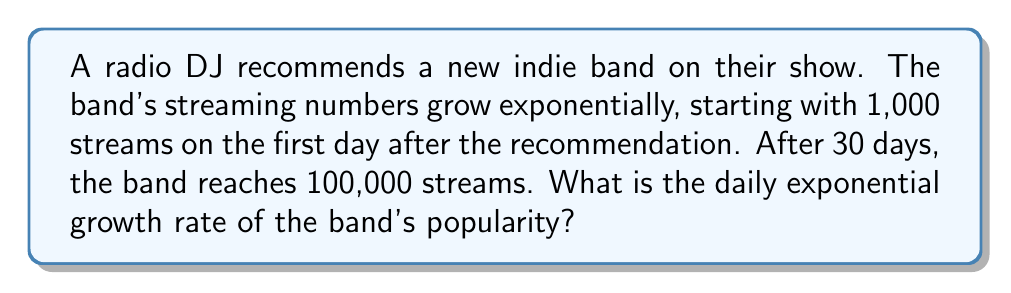Solve this math problem. Let's approach this step-by-step using the exponential growth formula:

1) The exponential growth formula is:
   $$A = P(1 + r)^t$$
   Where:
   $A$ = Final amount
   $P$ = Initial amount
   $r$ = Daily growth rate (in decimal form)
   $t$ = Time period (in days)

2) We know:
   $P = 1,000$ (initial streams)
   $A = 100,000$ (final streams)
   $t = 30$ days

3) Let's plug these into our formula:
   $$100,000 = 1,000(1 + r)^{30}$$

4) Simplify:
   $$100 = (1 + r)^{30}$$

5) Take the 30th root of both sides:
   $$\sqrt[30]{100} = 1 + r$$

6) Calculate:
   $$1.1552 = 1 + r$$

7) Solve for $r$:
   $$r = 1.1552 - 1 = 0.1552$$

8) Convert to percentage:
   $$0.1552 \times 100 = 15.52\%$$
Answer: 15.52% 